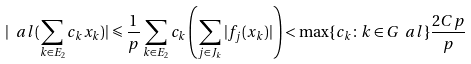<formula> <loc_0><loc_0><loc_500><loc_500>| \ a l ( \sum _ { k \in E _ { 2 } } c _ { k } x _ { k } ) | \leqslant \frac { 1 } { p } \sum _ { k \in E _ { 2 } } c _ { k } \left ( \sum _ { j \in J _ { k } } | f _ { j } ( x _ { k } ) | \right ) < \max \{ c _ { k } \colon k \in G _ { \ } a l \} \frac { 2 C p } { p }</formula> 